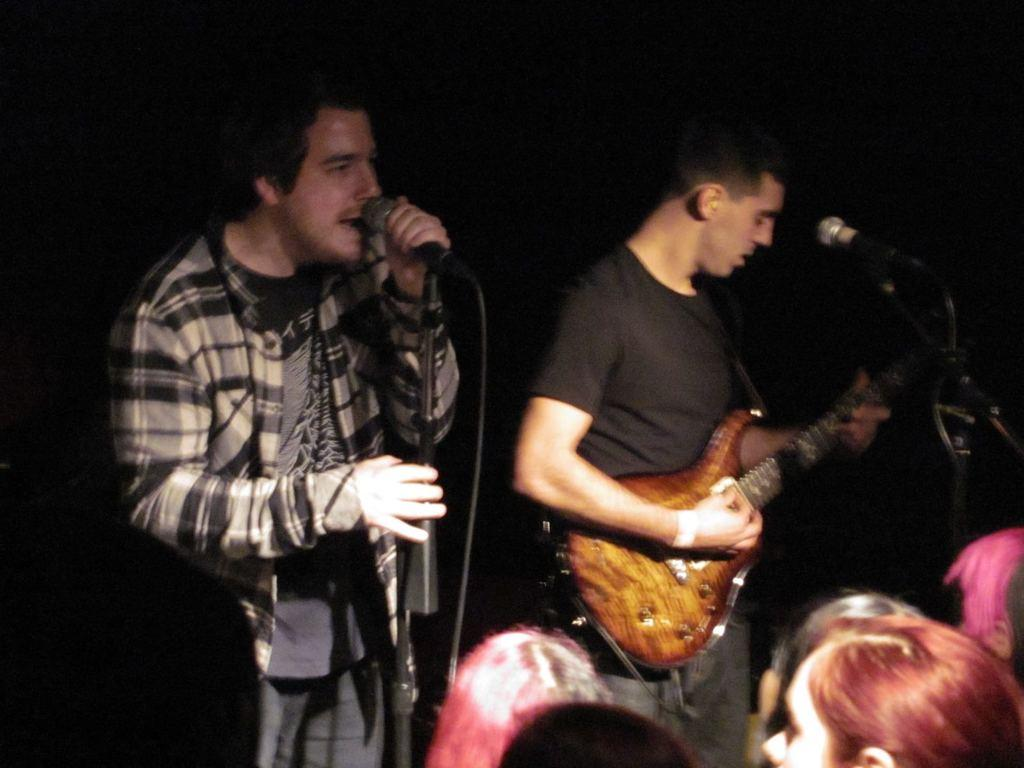What is the man in the image wearing? The man is wearing a jacket in the image. What is the man holding in the image? The man is holding a microphone in the image. What is the man doing with the microphone? The man is singing while holding the microphone. Can you describe the other man in the image? The other man is wearing a black t-shirt and playing a guitar. Where is the guitar-playing man positioned in relation to the microphone? The guitar-playing man is in front of a microphone. Who else is present in the image? There are people (audience) in the image. How much income does the rain generate in the image? There is no rain present in the image, and therefore no income can be generated from it. 